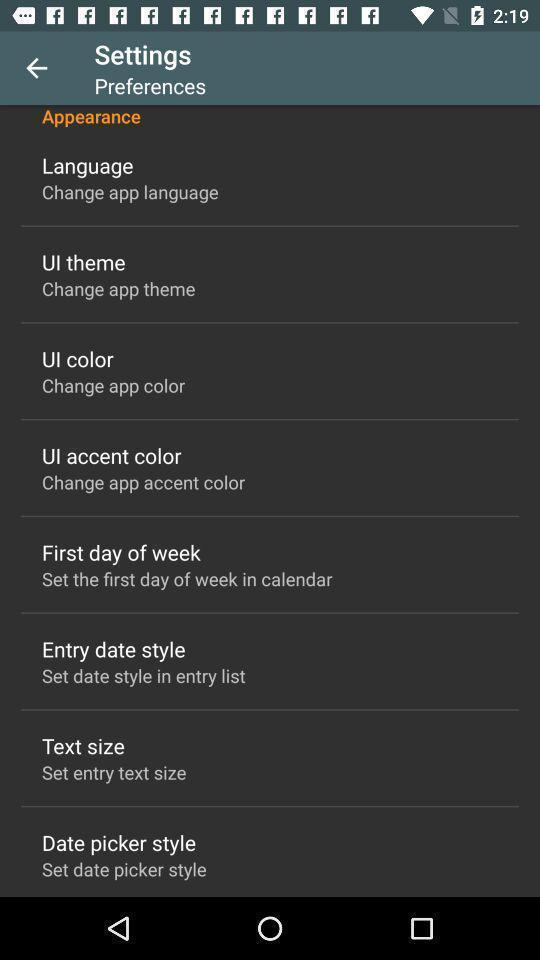Describe the content in this image. Page displaying with list of different settings. 